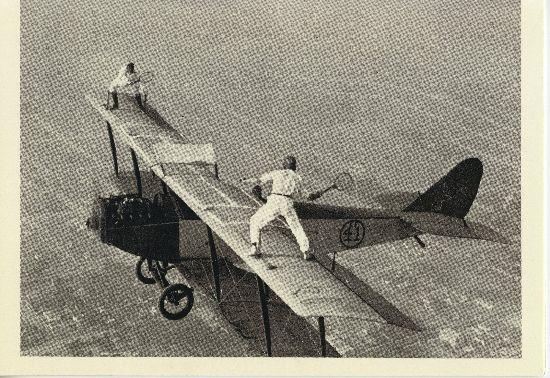What activity is the men on the plane part of?
Be succinct. Tennis. What is in the picture?
Be succinct. Airplane. Where is the man?
Give a very brief answer. On wing. Are the two men fighting on the plane?
Concise answer only. No. 